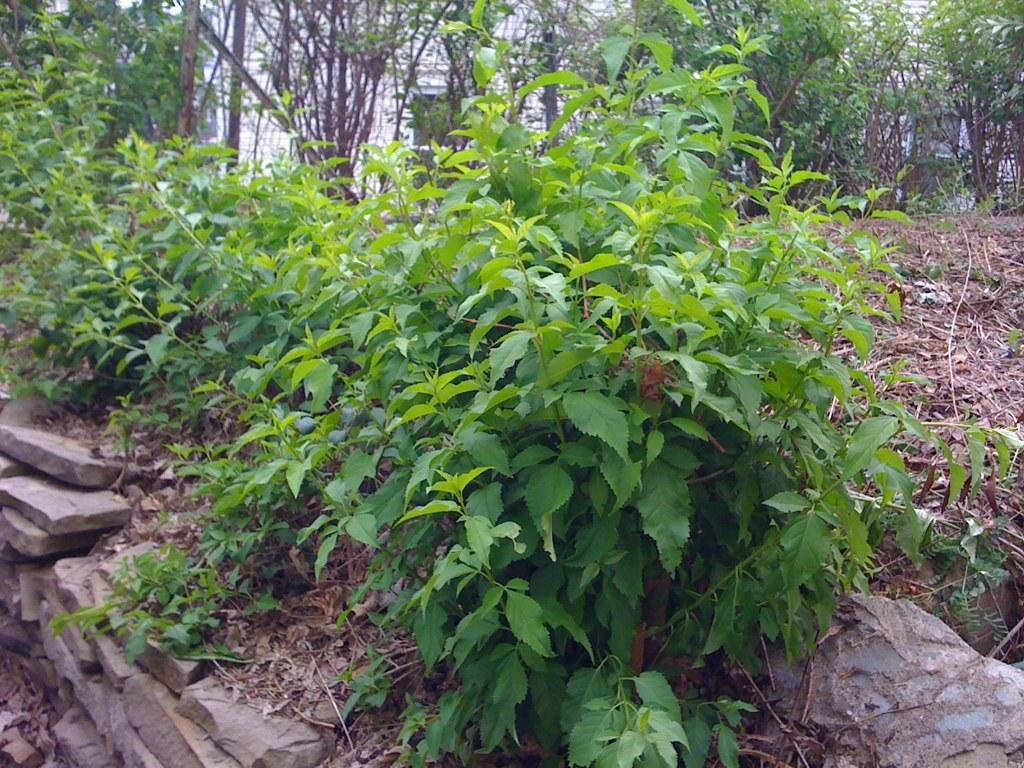What type of vegetation is present on the ground in the image? There are plants on the ground in the image. Where are the plants located in relation to other objects in the image? The plants are near a stone's wall. What can be seen in the background of the image? There are trees and a white color building in the background of the image. What type of knee injury can be seen in the image? There is no knee injury present in the image; it features plants on the ground near a stone's wall, trees, and a white color building in the background. 